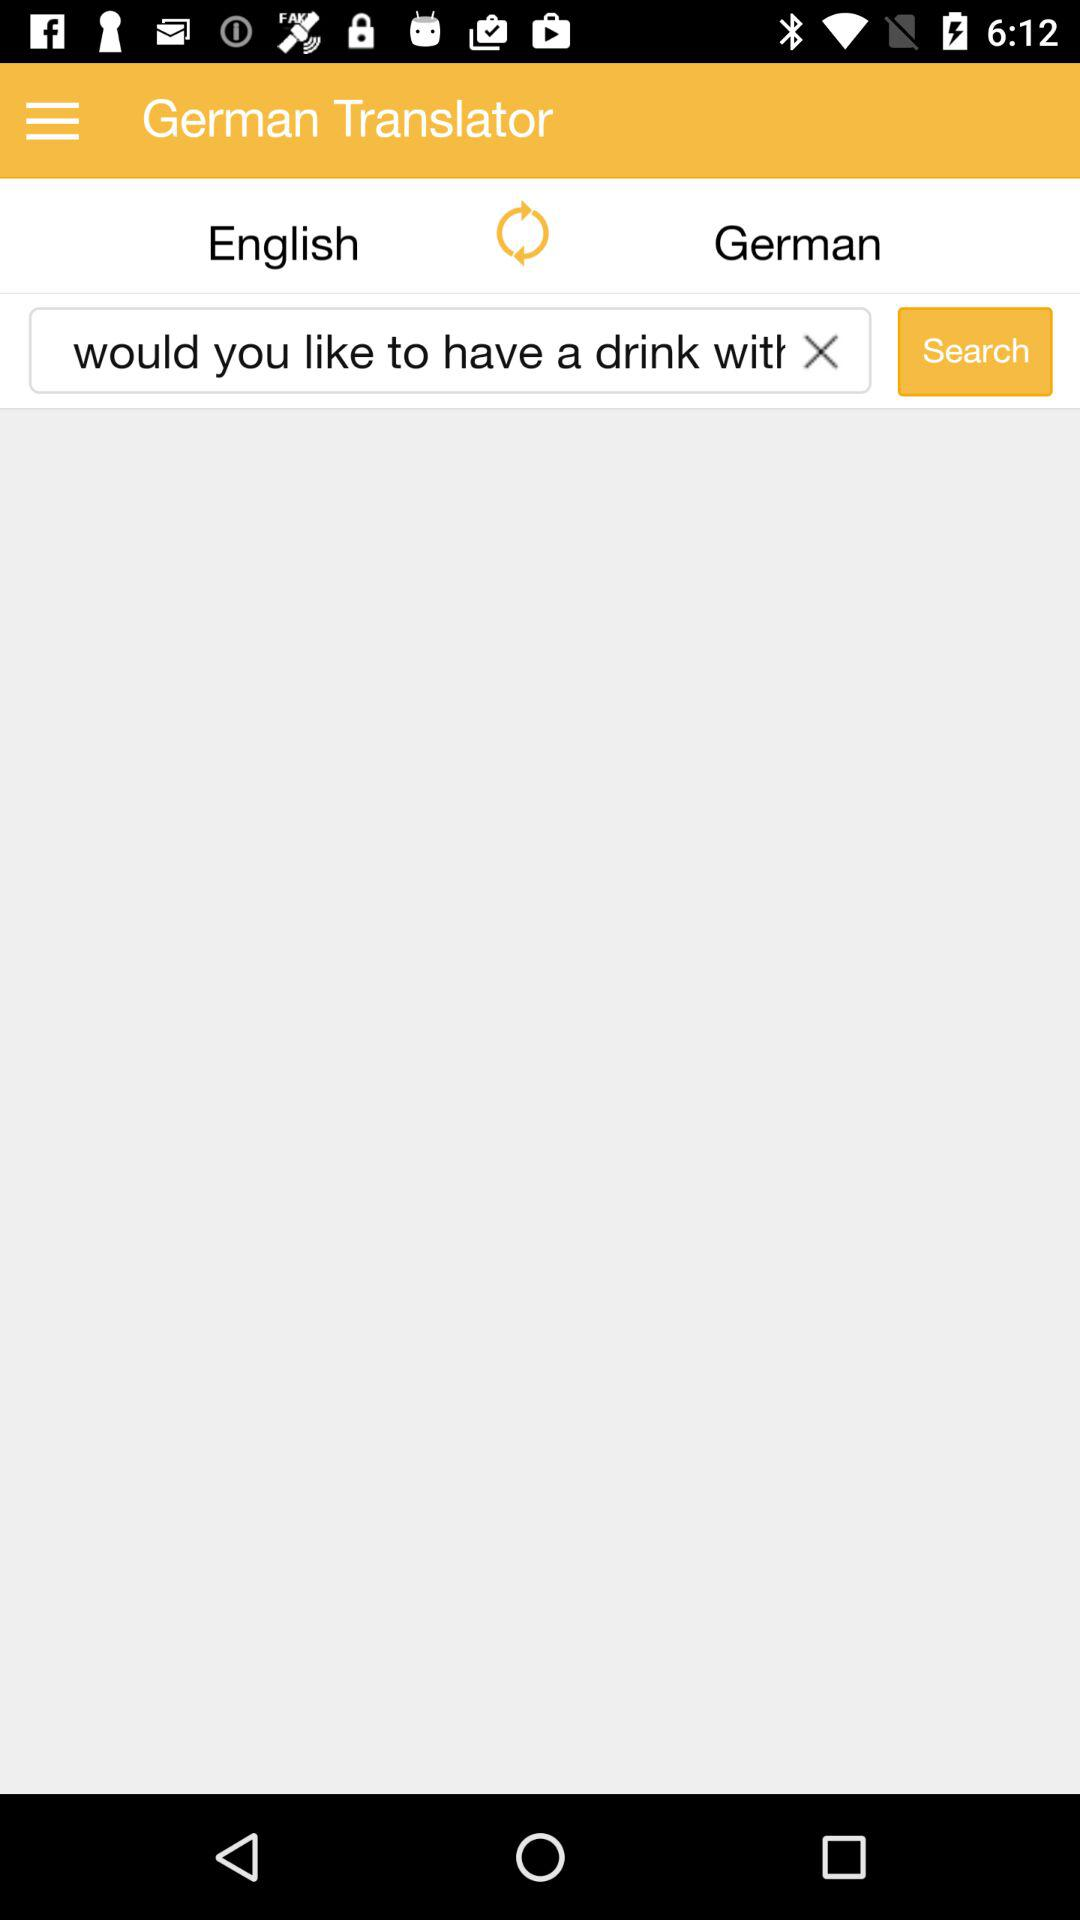What is the app name? The app name is "German Translator". 